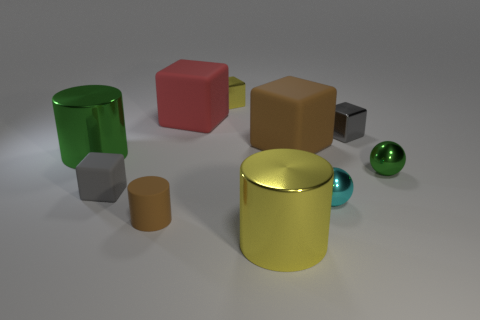Subtract all big green metal cylinders. How many cylinders are left? 2 Subtract 2 spheres. How many spheres are left? 0 Subtract all yellow cubes. How many cubes are left? 4 Add 8 tiny gray matte objects. How many tiny gray matte objects are left? 9 Add 5 rubber cylinders. How many rubber cylinders exist? 6 Subtract 0 blue spheres. How many objects are left? 10 Subtract all cylinders. How many objects are left? 7 Subtract all green cylinders. Subtract all gray blocks. How many cylinders are left? 2 Subtract all yellow blocks. How many blue spheres are left? 0 Subtract all small gray rubber objects. Subtract all brown cubes. How many objects are left? 8 